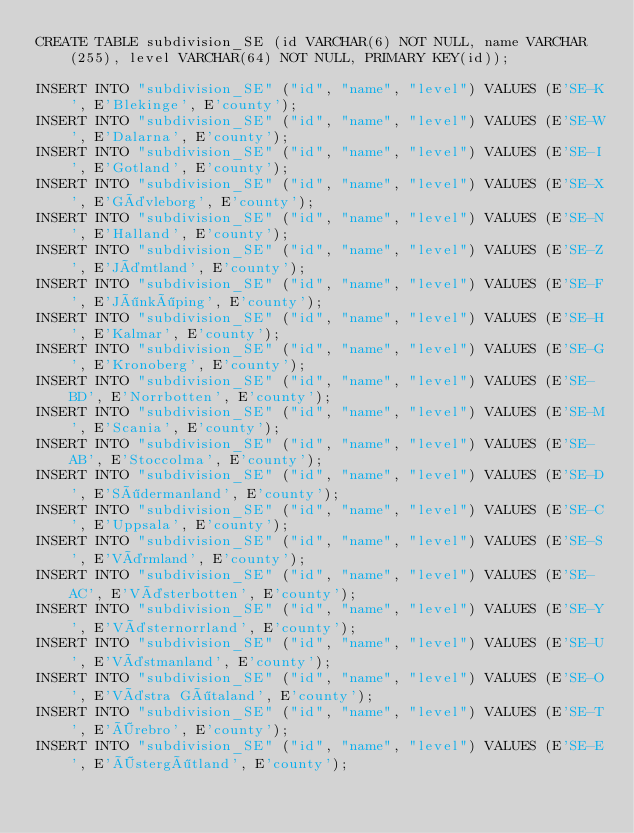Convert code to text. <code><loc_0><loc_0><loc_500><loc_500><_SQL_>CREATE TABLE subdivision_SE (id VARCHAR(6) NOT NULL, name VARCHAR(255), level VARCHAR(64) NOT NULL, PRIMARY KEY(id));

INSERT INTO "subdivision_SE" ("id", "name", "level") VALUES (E'SE-K', E'Blekinge', E'county');
INSERT INTO "subdivision_SE" ("id", "name", "level") VALUES (E'SE-W', E'Dalarna', E'county');
INSERT INTO "subdivision_SE" ("id", "name", "level") VALUES (E'SE-I', E'Gotland', E'county');
INSERT INTO "subdivision_SE" ("id", "name", "level") VALUES (E'SE-X', E'Gävleborg', E'county');
INSERT INTO "subdivision_SE" ("id", "name", "level") VALUES (E'SE-N', E'Halland', E'county');
INSERT INTO "subdivision_SE" ("id", "name", "level") VALUES (E'SE-Z', E'Jämtland', E'county');
INSERT INTO "subdivision_SE" ("id", "name", "level") VALUES (E'SE-F', E'Jönköping', E'county');
INSERT INTO "subdivision_SE" ("id", "name", "level") VALUES (E'SE-H', E'Kalmar', E'county');
INSERT INTO "subdivision_SE" ("id", "name", "level") VALUES (E'SE-G', E'Kronoberg', E'county');
INSERT INTO "subdivision_SE" ("id", "name", "level") VALUES (E'SE-BD', E'Norrbotten', E'county');
INSERT INTO "subdivision_SE" ("id", "name", "level") VALUES (E'SE-M', E'Scania', E'county');
INSERT INTO "subdivision_SE" ("id", "name", "level") VALUES (E'SE-AB', E'Stoccolma', E'county');
INSERT INTO "subdivision_SE" ("id", "name", "level") VALUES (E'SE-D', E'Södermanland', E'county');
INSERT INTO "subdivision_SE" ("id", "name", "level") VALUES (E'SE-C', E'Uppsala', E'county');
INSERT INTO "subdivision_SE" ("id", "name", "level") VALUES (E'SE-S', E'Värmland', E'county');
INSERT INTO "subdivision_SE" ("id", "name", "level") VALUES (E'SE-AC', E'Västerbotten', E'county');
INSERT INTO "subdivision_SE" ("id", "name", "level") VALUES (E'SE-Y', E'Västernorrland', E'county');
INSERT INTO "subdivision_SE" ("id", "name", "level") VALUES (E'SE-U', E'Västmanland', E'county');
INSERT INTO "subdivision_SE" ("id", "name", "level") VALUES (E'SE-O', E'Västra Götaland', E'county');
INSERT INTO "subdivision_SE" ("id", "name", "level") VALUES (E'SE-T', E'Örebro', E'county');
INSERT INTO "subdivision_SE" ("id", "name", "level") VALUES (E'SE-E', E'Östergötland', E'county');
</code> 